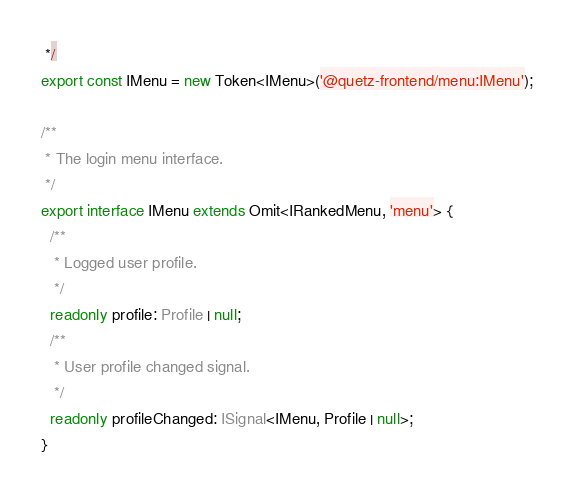Convert code to text. <code><loc_0><loc_0><loc_500><loc_500><_TypeScript_> */
export const IMenu = new Token<IMenu>('@quetz-frontend/menu:IMenu');

/**
 * The login menu interface.
 */
export interface IMenu extends Omit<IRankedMenu, 'menu'> {
  /**
   * Logged user profile.
   */
  readonly profile: Profile | null;
  /**
   * User profile changed signal.
   */
  readonly profileChanged: ISignal<IMenu, Profile | null>;
}
</code> 